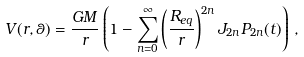Convert formula to latex. <formula><loc_0><loc_0><loc_500><loc_500>V ( r , \theta ) = \frac { G M } { r } \left ( 1 - \sum _ { n = 0 } ^ { \infty } \left ( \frac { R _ { e q } } { r } \right ) ^ { 2 n } J _ { 2 n } P _ { 2 n } ( t ) \right ) \, ,</formula> 